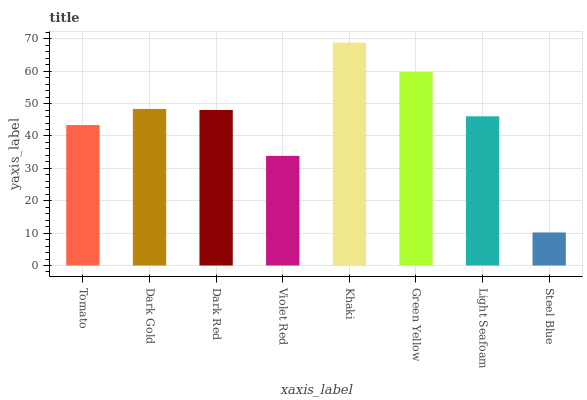Is Khaki the maximum?
Answer yes or no. Yes. Is Dark Gold the minimum?
Answer yes or no. No. Is Dark Gold the maximum?
Answer yes or no. No. Is Dark Gold greater than Tomato?
Answer yes or no. Yes. Is Tomato less than Dark Gold?
Answer yes or no. Yes. Is Tomato greater than Dark Gold?
Answer yes or no. No. Is Dark Gold less than Tomato?
Answer yes or no. No. Is Dark Red the high median?
Answer yes or no. Yes. Is Light Seafoam the low median?
Answer yes or no. Yes. Is Violet Red the high median?
Answer yes or no. No. Is Dark Gold the low median?
Answer yes or no. No. 